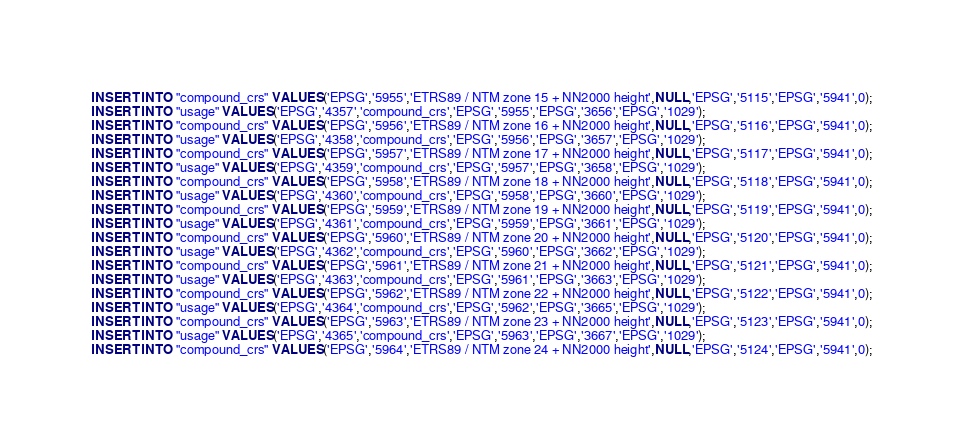<code> <loc_0><loc_0><loc_500><loc_500><_SQL_>INSERT INTO "compound_crs" VALUES('EPSG','5955','ETRS89 / NTM zone 15 + NN2000 height',NULL,'EPSG','5115','EPSG','5941',0);
INSERT INTO "usage" VALUES('EPSG','4357','compound_crs','EPSG','5955','EPSG','3656','EPSG','1029');
INSERT INTO "compound_crs" VALUES('EPSG','5956','ETRS89 / NTM zone 16 + NN2000 height',NULL,'EPSG','5116','EPSG','5941',0);
INSERT INTO "usage" VALUES('EPSG','4358','compound_crs','EPSG','5956','EPSG','3657','EPSG','1029');
INSERT INTO "compound_crs" VALUES('EPSG','5957','ETRS89 / NTM zone 17 + NN2000 height',NULL,'EPSG','5117','EPSG','5941',0);
INSERT INTO "usage" VALUES('EPSG','4359','compound_crs','EPSG','5957','EPSG','3658','EPSG','1029');
INSERT INTO "compound_crs" VALUES('EPSG','5958','ETRS89 / NTM zone 18 + NN2000 height',NULL,'EPSG','5118','EPSG','5941',0);
INSERT INTO "usage" VALUES('EPSG','4360','compound_crs','EPSG','5958','EPSG','3660','EPSG','1029');
INSERT INTO "compound_crs" VALUES('EPSG','5959','ETRS89 / NTM zone 19 + NN2000 height',NULL,'EPSG','5119','EPSG','5941',0);
INSERT INTO "usage" VALUES('EPSG','4361','compound_crs','EPSG','5959','EPSG','3661','EPSG','1029');
INSERT INTO "compound_crs" VALUES('EPSG','5960','ETRS89 / NTM zone 20 + NN2000 height',NULL,'EPSG','5120','EPSG','5941',0);
INSERT INTO "usage" VALUES('EPSG','4362','compound_crs','EPSG','5960','EPSG','3662','EPSG','1029');
INSERT INTO "compound_crs" VALUES('EPSG','5961','ETRS89 / NTM zone 21 + NN2000 height',NULL,'EPSG','5121','EPSG','5941',0);
INSERT INTO "usage" VALUES('EPSG','4363','compound_crs','EPSG','5961','EPSG','3663','EPSG','1029');
INSERT INTO "compound_crs" VALUES('EPSG','5962','ETRS89 / NTM zone 22 + NN2000 height',NULL,'EPSG','5122','EPSG','5941',0);
INSERT INTO "usage" VALUES('EPSG','4364','compound_crs','EPSG','5962','EPSG','3665','EPSG','1029');
INSERT INTO "compound_crs" VALUES('EPSG','5963','ETRS89 / NTM zone 23 + NN2000 height',NULL,'EPSG','5123','EPSG','5941',0);
INSERT INTO "usage" VALUES('EPSG','4365','compound_crs','EPSG','5963','EPSG','3667','EPSG','1029');
INSERT INTO "compound_crs" VALUES('EPSG','5964','ETRS89 / NTM zone 24 + NN2000 height',NULL,'EPSG','5124','EPSG','5941',0);</code> 